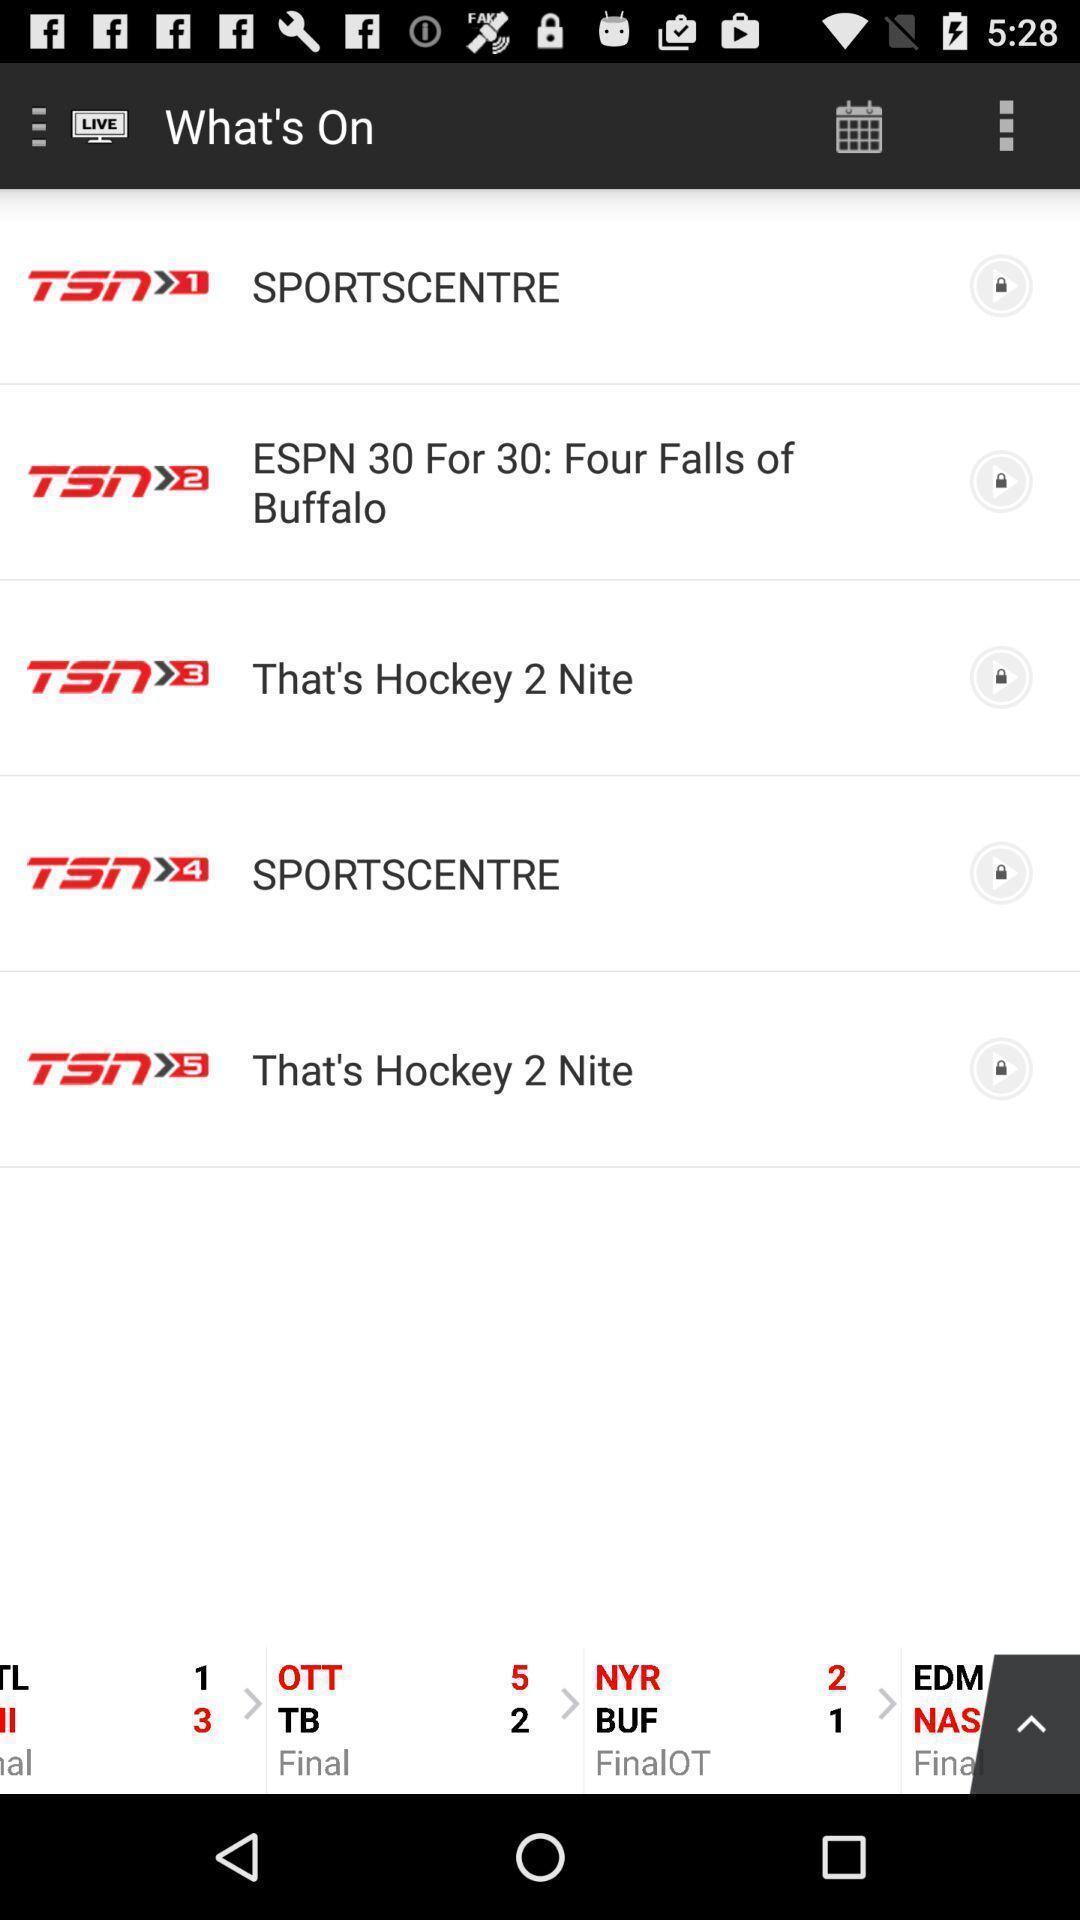Give me a narrative description of this picture. Screen page of a sports application. 